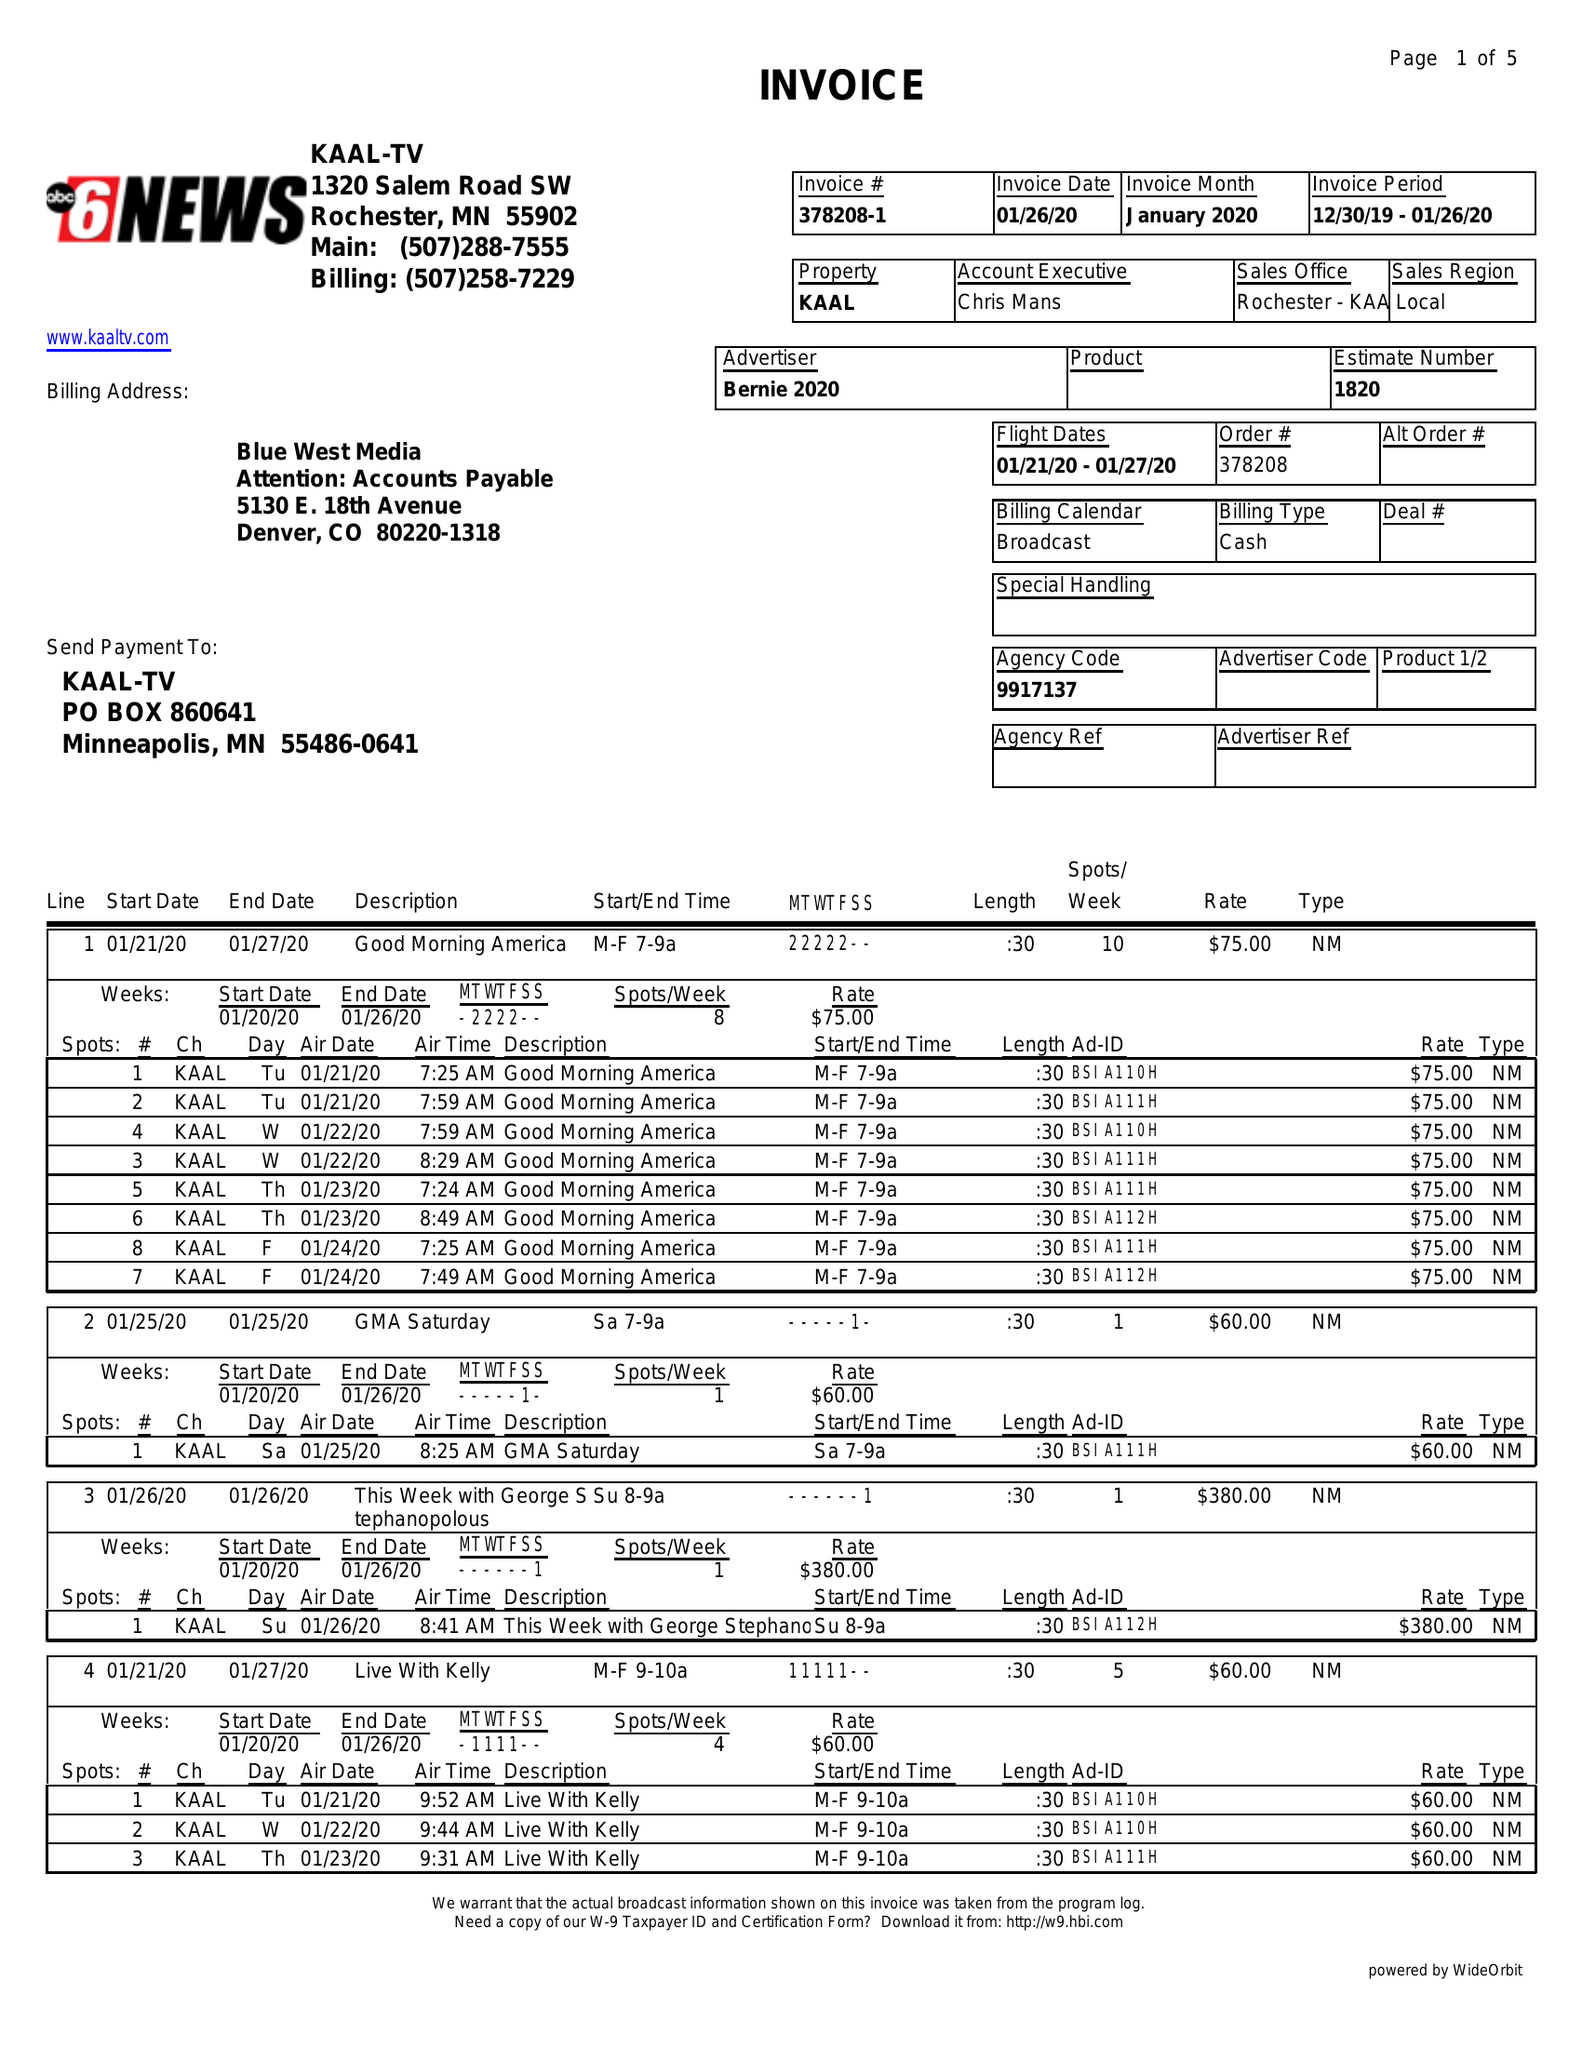What is the value for the advertiser?
Answer the question using a single word or phrase. BERNIE 2020 